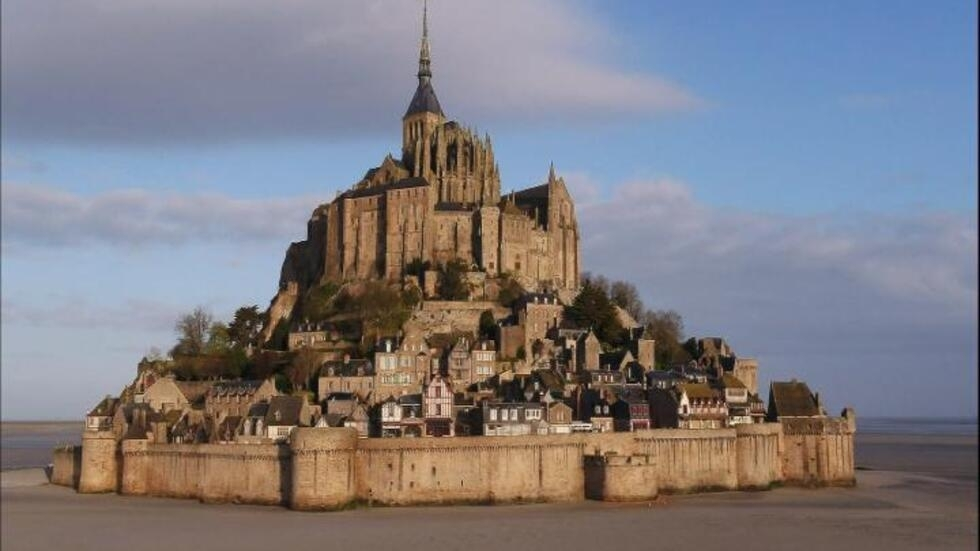What makes Mont Saint Michel a UNESCO World Heritage Site? Mont Saint Michel is a UNESCO World Heritage Site because of its historical, cultural, and architectural significance. It represents a unique blend of natural and human-made landscapes, showcasing medieval monastic architecture at its finest. The site's well-preserved history reflects the ebb and flow of European history, particularly during the Middle Ages. Its strategic significance, coupled with the stunning natural phenomena of the tides, make Mont Saint Michel an iconic symbol of human resilience, creativity, and spirituality. 